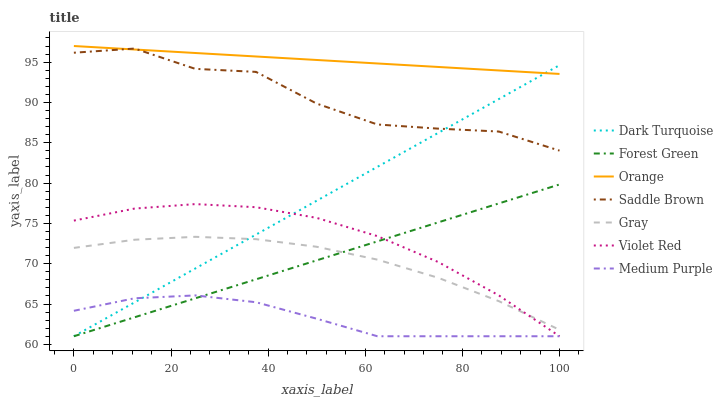Does Medium Purple have the minimum area under the curve?
Answer yes or no. Yes. Does Orange have the maximum area under the curve?
Answer yes or no. Yes. Does Violet Red have the minimum area under the curve?
Answer yes or no. No. Does Violet Red have the maximum area under the curve?
Answer yes or no. No. Is Forest Green the smoothest?
Answer yes or no. Yes. Is Saddle Brown the roughest?
Answer yes or no. Yes. Is Violet Red the smoothest?
Answer yes or no. No. Is Violet Red the roughest?
Answer yes or no. No. Does Orange have the lowest value?
Answer yes or no. No. Does Orange have the highest value?
Answer yes or no. Yes. Does Violet Red have the highest value?
Answer yes or no. No. Is Violet Red less than Orange?
Answer yes or no. Yes. Is Saddle Brown greater than Medium Purple?
Answer yes or no. Yes. Does Dark Turquoise intersect Violet Red?
Answer yes or no. Yes. Is Dark Turquoise less than Violet Red?
Answer yes or no. No. Is Dark Turquoise greater than Violet Red?
Answer yes or no. No. Does Violet Red intersect Orange?
Answer yes or no. No. 